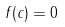<formula> <loc_0><loc_0><loc_500><loc_500>f ( c ) = 0</formula> 